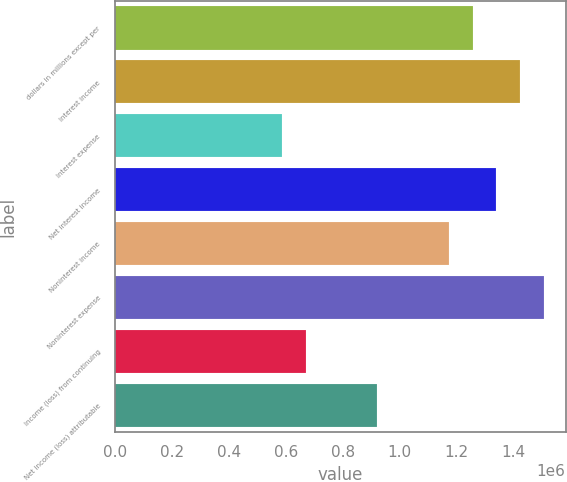<chart> <loc_0><loc_0><loc_500><loc_500><bar_chart><fcel>dollars in millions except per<fcel>Interest income<fcel>Interest expense<fcel>Net interest income<fcel>Noninterest income<fcel>Noninterest expense<fcel>Income (loss) from continuing<fcel>Net income (loss) attributable<nl><fcel>1.25527e+06<fcel>1.42264e+06<fcel>585792<fcel>1.33895e+06<fcel>1.17158e+06<fcel>1.50632e+06<fcel>669477<fcel>920531<nl></chart> 